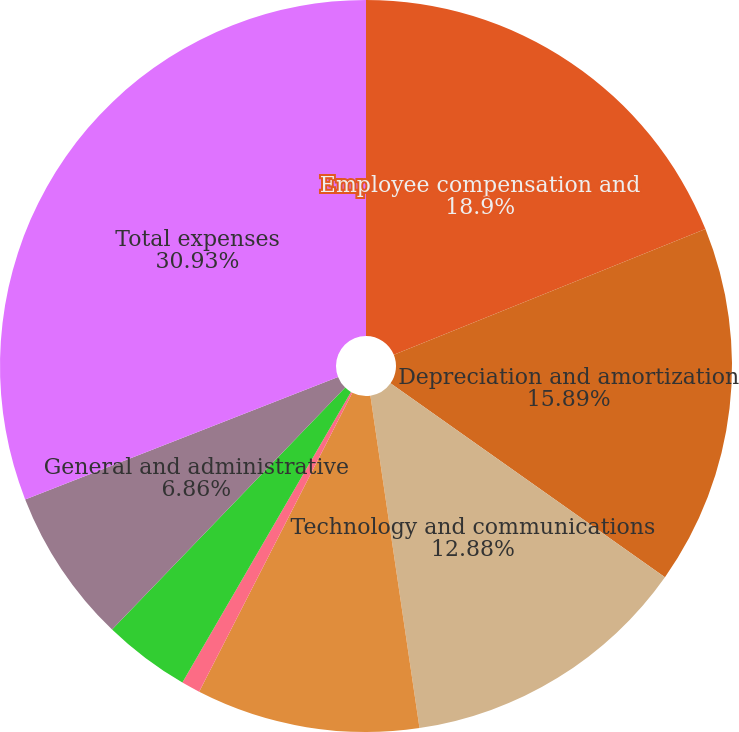Convert chart. <chart><loc_0><loc_0><loc_500><loc_500><pie_chart><fcel>Employee compensation and<fcel>Depreciation and amortization<fcel>Technology and communications<fcel>Professional and consulting<fcel>Occupancy<fcel>Marketing and advertising<fcel>General and administrative<fcel>Total expenses<nl><fcel>18.9%<fcel>15.89%<fcel>12.88%<fcel>9.87%<fcel>0.83%<fcel>3.84%<fcel>6.86%<fcel>30.94%<nl></chart> 